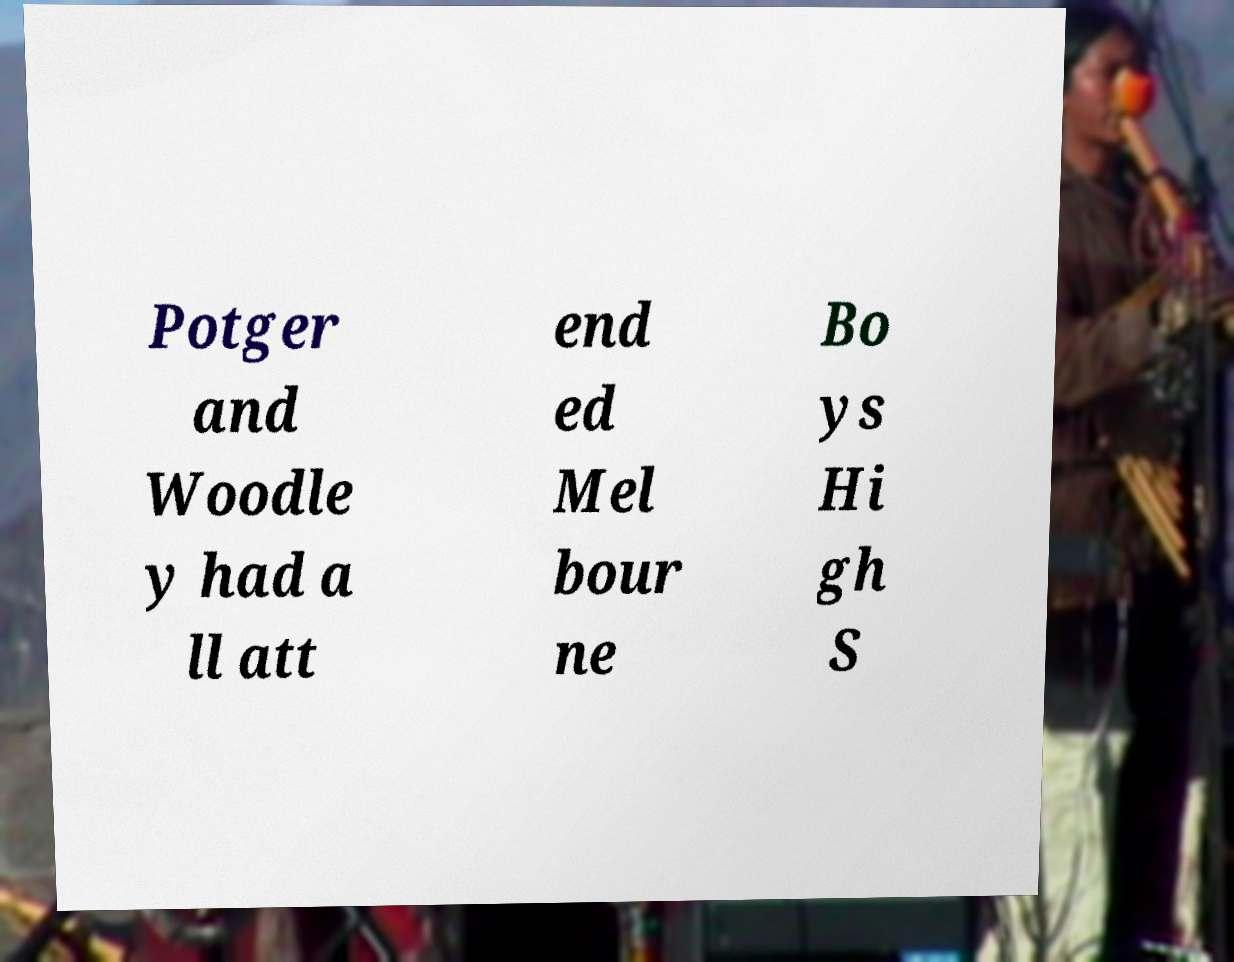I need the written content from this picture converted into text. Can you do that? Potger and Woodle y had a ll att end ed Mel bour ne Bo ys Hi gh S 